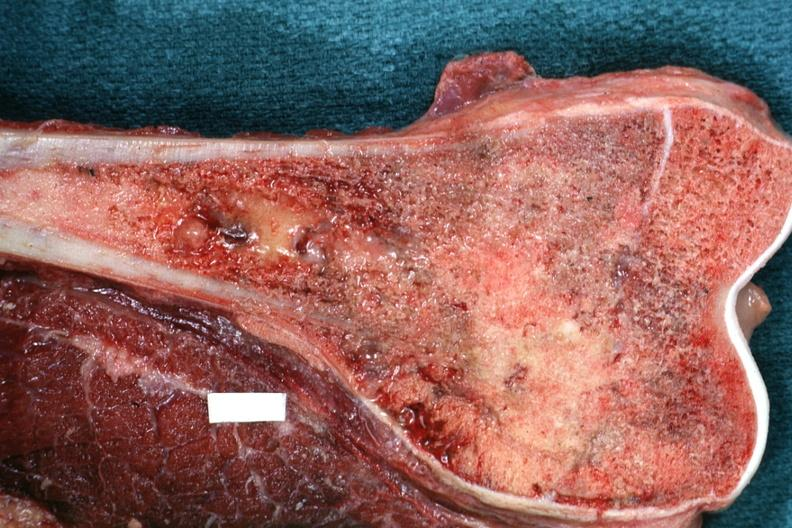what is present?
Answer the question using a single word or phrase. Joints 